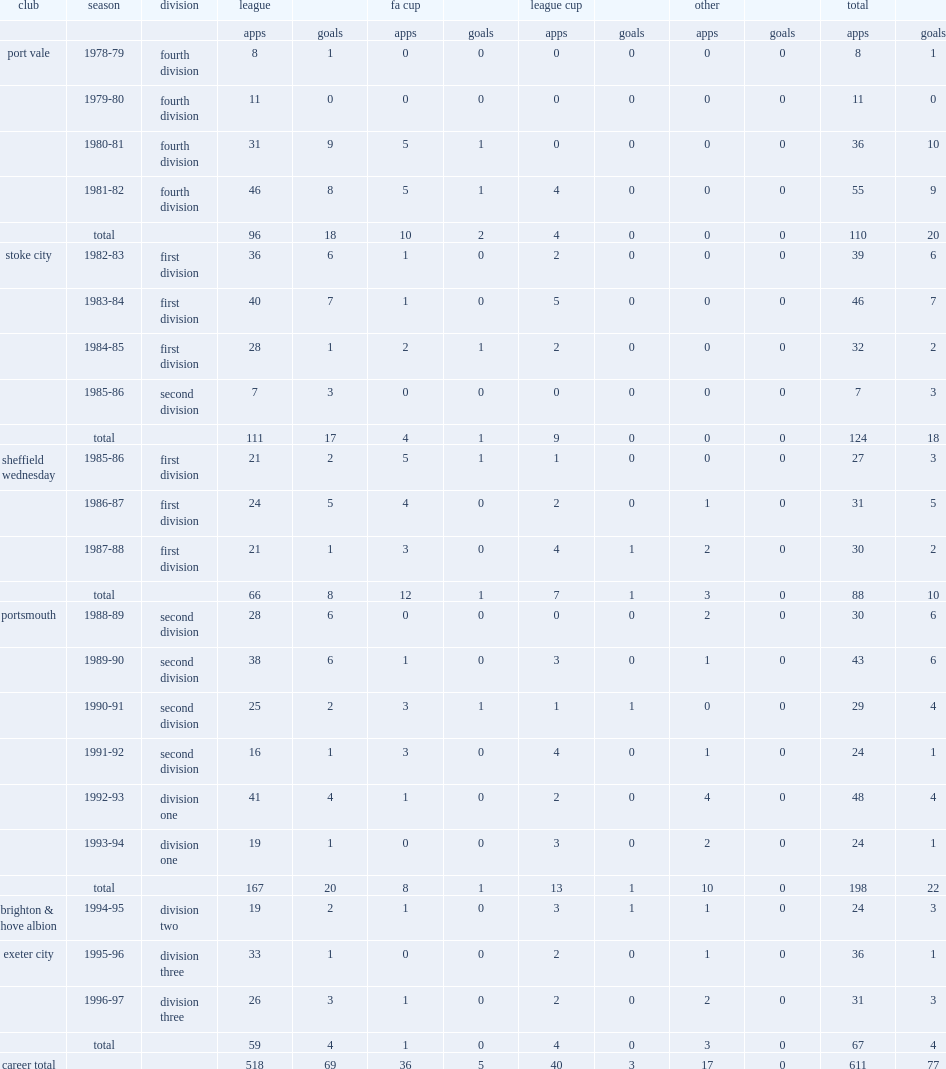Which club did chamberlain play for in 1994-95? Brighton & hove albion. 